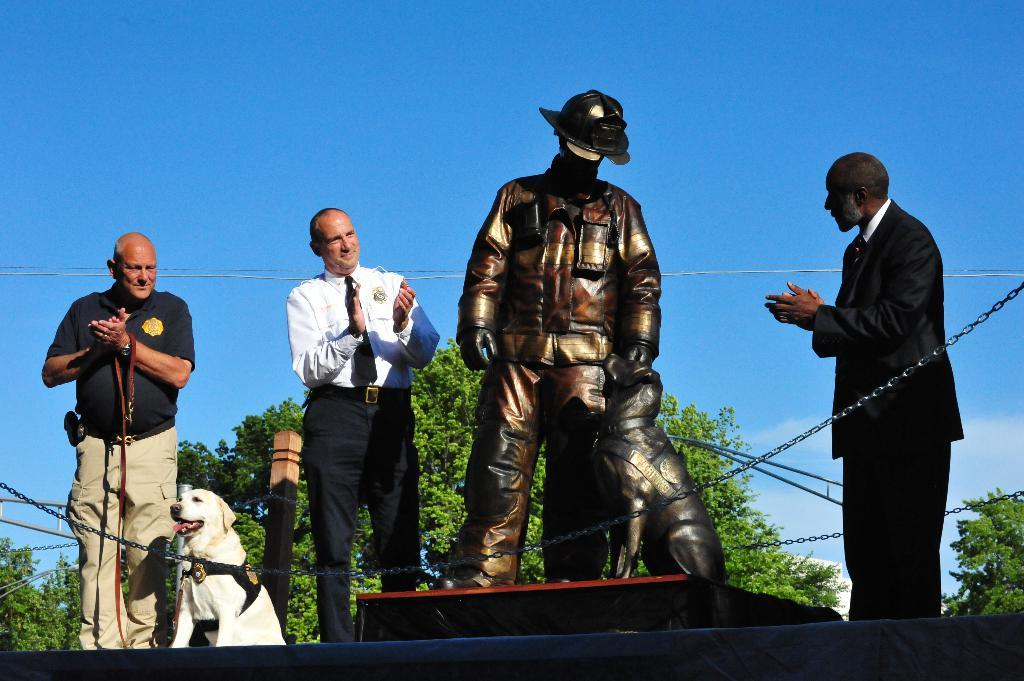Who or what can be seen in the image? There are people and a dog in the image. What else is present in the image besides the people and the dog? There is a sculpture of a man and a dog in the image. What type of clock is hanging on the wall in the image? There is no clock present in the image. How many cars are parked in front of the people in the image? There are no cars present in the image. 